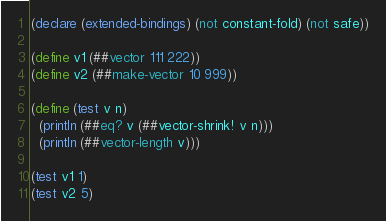Convert code to text. <code><loc_0><loc_0><loc_500><loc_500><_Scheme_>(declare (extended-bindings) (not constant-fold) (not safe))

(define v1 (##vector 111 222))
(define v2 (##make-vector 10 999))

(define (test v n)
  (println (##eq? v (##vector-shrink! v n)))
  (println (##vector-length v)))

(test v1 1)
(test v2 5)
</code> 